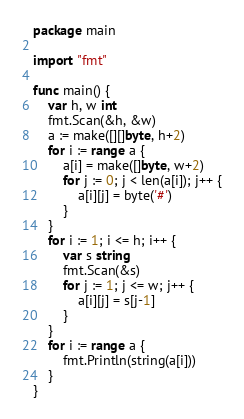Convert code to text. <code><loc_0><loc_0><loc_500><loc_500><_Go_>package main

import "fmt"

func main() {
	var h, w int
	fmt.Scan(&h, &w)
	a := make([][]byte, h+2)
	for i := range a {
		a[i] = make([]byte, w+2)
		for j := 0; j < len(a[i]); j++ {
			a[i][j] = byte('#')
		}
	}
	for i := 1; i <= h; i++ {
		var s string
		fmt.Scan(&s)
		for j := 1; j <= w; j++ {
			a[i][j] = s[j-1]
		}
	}
	for i := range a {
		fmt.Println(string(a[i]))
	}
}
</code> 